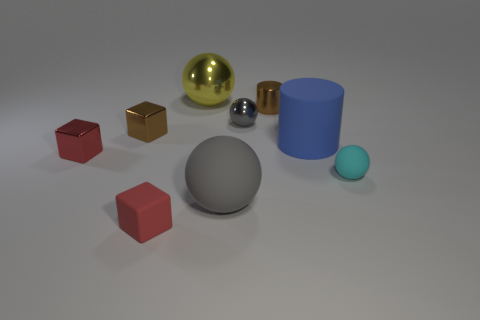Subtract all yellow metallic spheres. How many spheres are left? 3 Add 1 tiny things. How many objects exist? 10 Subtract 1 balls. How many balls are left? 3 Subtract all brown spheres. Subtract all yellow cubes. How many spheres are left? 4 Subtract all spheres. How many objects are left? 5 Subtract all red spheres. Subtract all big gray things. How many objects are left? 8 Add 5 tiny red cubes. How many tiny red cubes are left? 7 Add 9 small gray metal balls. How many small gray metal balls exist? 10 Subtract 0 purple cylinders. How many objects are left? 9 